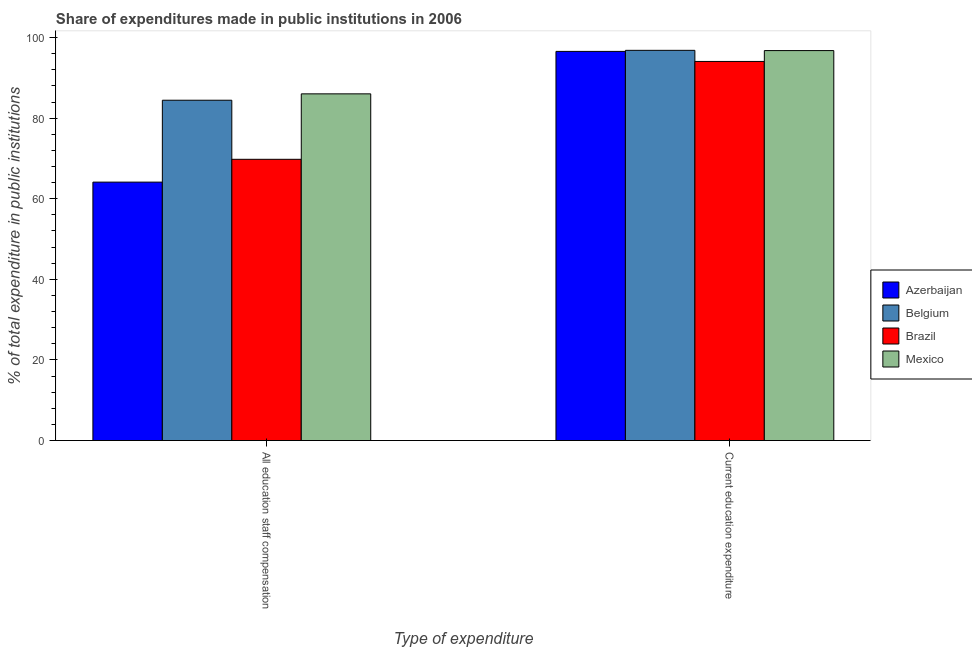How many different coloured bars are there?
Make the answer very short. 4. How many groups of bars are there?
Offer a very short reply. 2. Are the number of bars per tick equal to the number of legend labels?
Offer a very short reply. Yes. How many bars are there on the 1st tick from the left?
Ensure brevity in your answer.  4. What is the label of the 2nd group of bars from the left?
Offer a very short reply. Current education expenditure. What is the expenditure in staff compensation in Belgium?
Ensure brevity in your answer.  84.45. Across all countries, what is the maximum expenditure in staff compensation?
Provide a succinct answer. 86.03. Across all countries, what is the minimum expenditure in education?
Make the answer very short. 94.07. What is the total expenditure in education in the graph?
Make the answer very short. 384.21. What is the difference between the expenditure in staff compensation in Belgium and that in Azerbaijan?
Your answer should be compact. 20.32. What is the difference between the expenditure in education in Belgium and the expenditure in staff compensation in Brazil?
Give a very brief answer. 27.04. What is the average expenditure in education per country?
Offer a terse response. 96.05. What is the difference between the expenditure in education and expenditure in staff compensation in Belgium?
Ensure brevity in your answer.  12.38. What is the ratio of the expenditure in staff compensation in Azerbaijan to that in Belgium?
Your answer should be compact. 0.76. Is the expenditure in staff compensation in Brazil less than that in Azerbaijan?
Ensure brevity in your answer.  No. What does the 4th bar from the left in All education staff compensation represents?
Provide a short and direct response. Mexico. What does the 2nd bar from the right in Current education expenditure represents?
Offer a very short reply. Brazil. How many bars are there?
Offer a very short reply. 8. Are all the bars in the graph horizontal?
Provide a short and direct response. No. How many countries are there in the graph?
Provide a succinct answer. 4. What is the difference between two consecutive major ticks on the Y-axis?
Offer a very short reply. 20. Are the values on the major ticks of Y-axis written in scientific E-notation?
Make the answer very short. No. Does the graph contain any zero values?
Make the answer very short. No. How many legend labels are there?
Your answer should be very brief. 4. What is the title of the graph?
Offer a very short reply. Share of expenditures made in public institutions in 2006. What is the label or title of the X-axis?
Offer a terse response. Type of expenditure. What is the label or title of the Y-axis?
Give a very brief answer. % of total expenditure in public institutions. What is the % of total expenditure in public institutions in Azerbaijan in All education staff compensation?
Provide a succinct answer. 64.13. What is the % of total expenditure in public institutions in Belgium in All education staff compensation?
Offer a terse response. 84.45. What is the % of total expenditure in public institutions of Brazil in All education staff compensation?
Your answer should be compact. 69.78. What is the % of total expenditure in public institutions of Mexico in All education staff compensation?
Give a very brief answer. 86.03. What is the % of total expenditure in public institutions in Azerbaijan in Current education expenditure?
Offer a very short reply. 96.56. What is the % of total expenditure in public institutions of Belgium in Current education expenditure?
Your answer should be compact. 96.82. What is the % of total expenditure in public institutions of Brazil in Current education expenditure?
Offer a terse response. 94.07. What is the % of total expenditure in public institutions in Mexico in Current education expenditure?
Provide a short and direct response. 96.76. Across all Type of expenditure, what is the maximum % of total expenditure in public institutions of Azerbaijan?
Provide a short and direct response. 96.56. Across all Type of expenditure, what is the maximum % of total expenditure in public institutions in Belgium?
Your answer should be compact. 96.82. Across all Type of expenditure, what is the maximum % of total expenditure in public institutions of Brazil?
Provide a succinct answer. 94.07. Across all Type of expenditure, what is the maximum % of total expenditure in public institutions of Mexico?
Keep it short and to the point. 96.76. Across all Type of expenditure, what is the minimum % of total expenditure in public institutions of Azerbaijan?
Provide a short and direct response. 64.13. Across all Type of expenditure, what is the minimum % of total expenditure in public institutions in Belgium?
Make the answer very short. 84.45. Across all Type of expenditure, what is the minimum % of total expenditure in public institutions of Brazil?
Provide a succinct answer. 69.78. Across all Type of expenditure, what is the minimum % of total expenditure in public institutions of Mexico?
Your response must be concise. 86.03. What is the total % of total expenditure in public institutions in Azerbaijan in the graph?
Keep it short and to the point. 160.68. What is the total % of total expenditure in public institutions of Belgium in the graph?
Make the answer very short. 181.27. What is the total % of total expenditure in public institutions in Brazil in the graph?
Offer a very short reply. 163.85. What is the total % of total expenditure in public institutions in Mexico in the graph?
Ensure brevity in your answer.  182.79. What is the difference between the % of total expenditure in public institutions in Azerbaijan in All education staff compensation and that in Current education expenditure?
Ensure brevity in your answer.  -32.43. What is the difference between the % of total expenditure in public institutions of Belgium in All education staff compensation and that in Current education expenditure?
Your answer should be compact. -12.38. What is the difference between the % of total expenditure in public institutions in Brazil in All education staff compensation and that in Current education expenditure?
Your answer should be compact. -24.28. What is the difference between the % of total expenditure in public institutions in Mexico in All education staff compensation and that in Current education expenditure?
Your answer should be very brief. -10.74. What is the difference between the % of total expenditure in public institutions of Azerbaijan in All education staff compensation and the % of total expenditure in public institutions of Belgium in Current education expenditure?
Offer a very short reply. -32.7. What is the difference between the % of total expenditure in public institutions in Azerbaijan in All education staff compensation and the % of total expenditure in public institutions in Brazil in Current education expenditure?
Provide a short and direct response. -29.94. What is the difference between the % of total expenditure in public institutions in Azerbaijan in All education staff compensation and the % of total expenditure in public institutions in Mexico in Current education expenditure?
Make the answer very short. -32.64. What is the difference between the % of total expenditure in public institutions in Belgium in All education staff compensation and the % of total expenditure in public institutions in Brazil in Current education expenditure?
Keep it short and to the point. -9.62. What is the difference between the % of total expenditure in public institutions of Belgium in All education staff compensation and the % of total expenditure in public institutions of Mexico in Current education expenditure?
Your answer should be very brief. -12.32. What is the difference between the % of total expenditure in public institutions in Brazil in All education staff compensation and the % of total expenditure in public institutions in Mexico in Current education expenditure?
Offer a very short reply. -26.98. What is the average % of total expenditure in public institutions of Azerbaijan per Type of expenditure?
Provide a succinct answer. 80.34. What is the average % of total expenditure in public institutions in Belgium per Type of expenditure?
Offer a terse response. 90.63. What is the average % of total expenditure in public institutions in Brazil per Type of expenditure?
Ensure brevity in your answer.  81.93. What is the average % of total expenditure in public institutions of Mexico per Type of expenditure?
Ensure brevity in your answer.  91.39. What is the difference between the % of total expenditure in public institutions of Azerbaijan and % of total expenditure in public institutions of Belgium in All education staff compensation?
Offer a terse response. -20.32. What is the difference between the % of total expenditure in public institutions of Azerbaijan and % of total expenditure in public institutions of Brazil in All education staff compensation?
Provide a succinct answer. -5.66. What is the difference between the % of total expenditure in public institutions of Azerbaijan and % of total expenditure in public institutions of Mexico in All education staff compensation?
Your answer should be compact. -21.9. What is the difference between the % of total expenditure in public institutions of Belgium and % of total expenditure in public institutions of Brazil in All education staff compensation?
Provide a succinct answer. 14.66. What is the difference between the % of total expenditure in public institutions in Belgium and % of total expenditure in public institutions in Mexico in All education staff compensation?
Make the answer very short. -1.58. What is the difference between the % of total expenditure in public institutions in Brazil and % of total expenditure in public institutions in Mexico in All education staff compensation?
Make the answer very short. -16.24. What is the difference between the % of total expenditure in public institutions of Azerbaijan and % of total expenditure in public institutions of Belgium in Current education expenditure?
Your answer should be very brief. -0.26. What is the difference between the % of total expenditure in public institutions in Azerbaijan and % of total expenditure in public institutions in Brazil in Current education expenditure?
Offer a terse response. 2.49. What is the difference between the % of total expenditure in public institutions of Azerbaijan and % of total expenditure in public institutions of Mexico in Current education expenditure?
Ensure brevity in your answer.  -0.2. What is the difference between the % of total expenditure in public institutions of Belgium and % of total expenditure in public institutions of Brazil in Current education expenditure?
Make the answer very short. 2.75. What is the difference between the % of total expenditure in public institutions in Belgium and % of total expenditure in public institutions in Mexico in Current education expenditure?
Your answer should be very brief. 0.06. What is the difference between the % of total expenditure in public institutions of Brazil and % of total expenditure in public institutions of Mexico in Current education expenditure?
Make the answer very short. -2.69. What is the ratio of the % of total expenditure in public institutions of Azerbaijan in All education staff compensation to that in Current education expenditure?
Provide a succinct answer. 0.66. What is the ratio of the % of total expenditure in public institutions of Belgium in All education staff compensation to that in Current education expenditure?
Provide a succinct answer. 0.87. What is the ratio of the % of total expenditure in public institutions of Brazil in All education staff compensation to that in Current education expenditure?
Make the answer very short. 0.74. What is the ratio of the % of total expenditure in public institutions in Mexico in All education staff compensation to that in Current education expenditure?
Give a very brief answer. 0.89. What is the difference between the highest and the second highest % of total expenditure in public institutions in Azerbaijan?
Your response must be concise. 32.43. What is the difference between the highest and the second highest % of total expenditure in public institutions in Belgium?
Provide a succinct answer. 12.38. What is the difference between the highest and the second highest % of total expenditure in public institutions of Brazil?
Your response must be concise. 24.28. What is the difference between the highest and the second highest % of total expenditure in public institutions in Mexico?
Provide a short and direct response. 10.74. What is the difference between the highest and the lowest % of total expenditure in public institutions of Azerbaijan?
Ensure brevity in your answer.  32.43. What is the difference between the highest and the lowest % of total expenditure in public institutions in Belgium?
Your answer should be very brief. 12.38. What is the difference between the highest and the lowest % of total expenditure in public institutions in Brazil?
Keep it short and to the point. 24.28. What is the difference between the highest and the lowest % of total expenditure in public institutions of Mexico?
Provide a succinct answer. 10.74. 